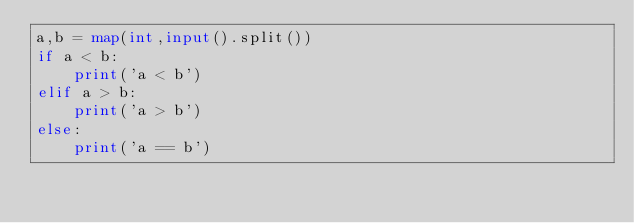Convert code to text. <code><loc_0><loc_0><loc_500><loc_500><_Python_>a,b = map(int,input().split())
if a < b:
    print('a < b')
elif a > b:
    print('a > b')
else:
    print('a == b')
</code> 